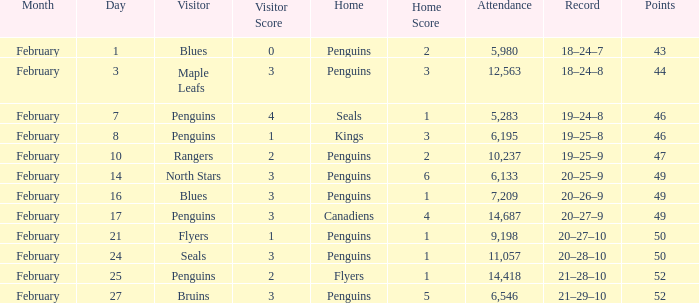What score did the home of kings have? 1–3. 